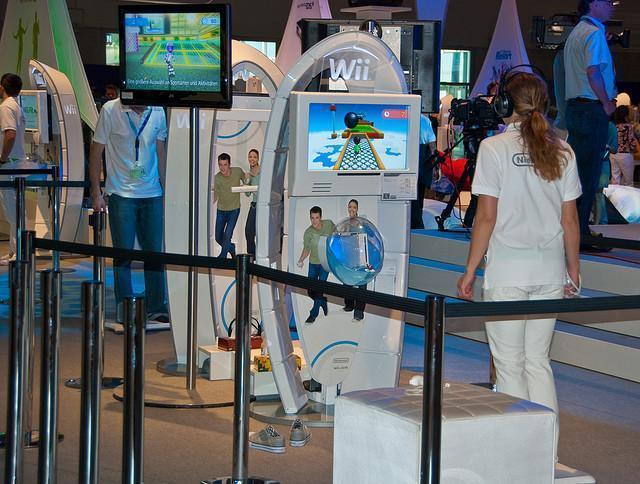What is the article of clothing at the base of the console used for?
Choose the correct response and explain in the format: 'Answer: answer
Rationale: rationale.'
Options: Bulletproofing, holding weights, protect eyes, walking. Answer: walking.
Rationale: The clothing is for walking. What consumer electronic company made the white gaming displays?
Choose the right answer from the provided options to respond to the question.
Options: Sega, sony, apple, nintendo. Nintendo. 